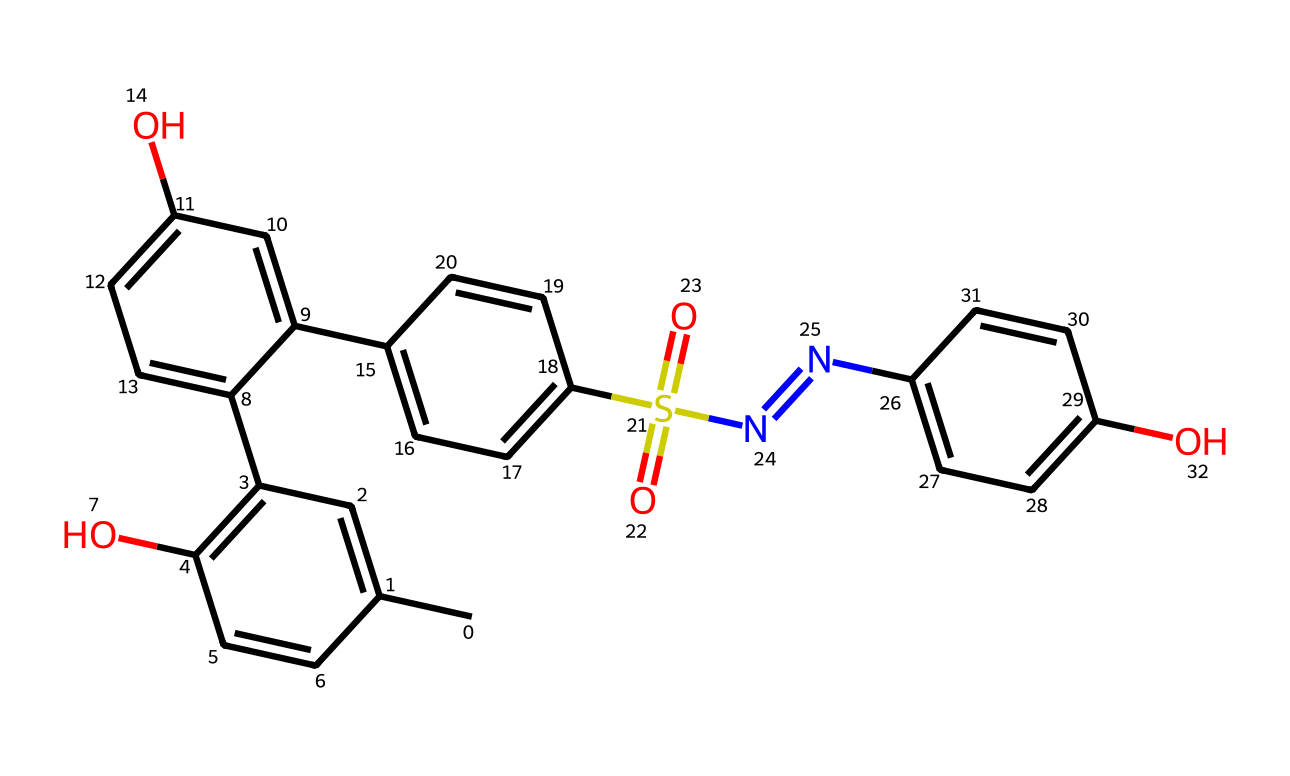What is the total number of carbon atoms in this photoresist? The SMILES representation shows multiple 'C' atoms. Counting each 'C' in the structure, we find that there are 17 carbon atoms total.
Answer: 17 How many hydroxyl (–OH) groups are present in this compound? The presence of the 'O' connected to 'C' indicates hydroxyl groups, and by analyzing the structure, we can identify that there are 3 such groups present.
Answer: 3 Which functional group is indicated by the presence of ‘N’ and ‘S(=O)(=O)’ in the structure? The presence of the 'N' atom, combined with the sulfur (S) and its double-bonded oxygen (O) atoms, suggests that this compound contains a sulfonamide functional group.
Answer: sulfonamide What type of bonding is predominant in the carbon ring structures observed here? The structure reveals multiple connections between carbon atoms, especially in cyclic formats indicating that there are significant aromatic bonding characteristics due to alternating double bonds.
Answer: aromatic What property of this photoresist is likely affected by the presence of sulfur? The presence of sulfur, as seen in the 'S(=O)(=O)' notation, suggests enhanced sensitivity to light, which is crucial for the photoresist's efficiency in exposing and developing processes in CD and DVD production.
Answer: light sensitivity How many nitrogen atoms can be identified in this photoresist? By identifying the instances of 'N' in the SMILES representation, it's clear that there is one nitrogen atom present in this particular structure.
Answer: 1 